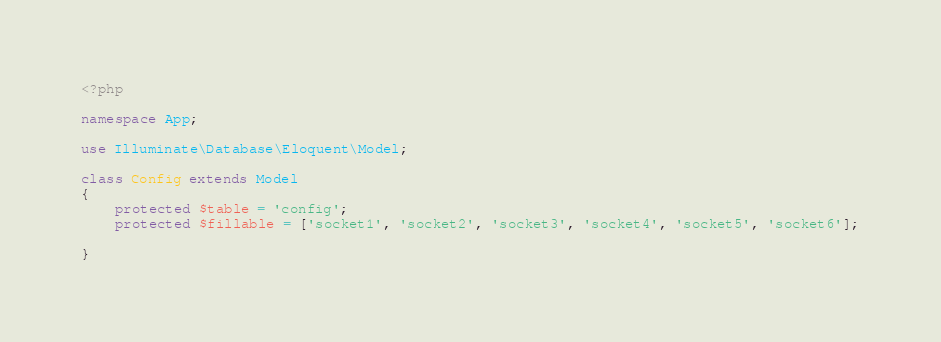<code> <loc_0><loc_0><loc_500><loc_500><_PHP_><?php

namespace App;

use Illuminate\Database\Eloquent\Model;

class Config extends Model
{
    protected $table = 'config';
    protected $fillable = ['socket1', 'socket2', 'socket3', 'socket4', 'socket5', 'socket6'];

}
</code> 